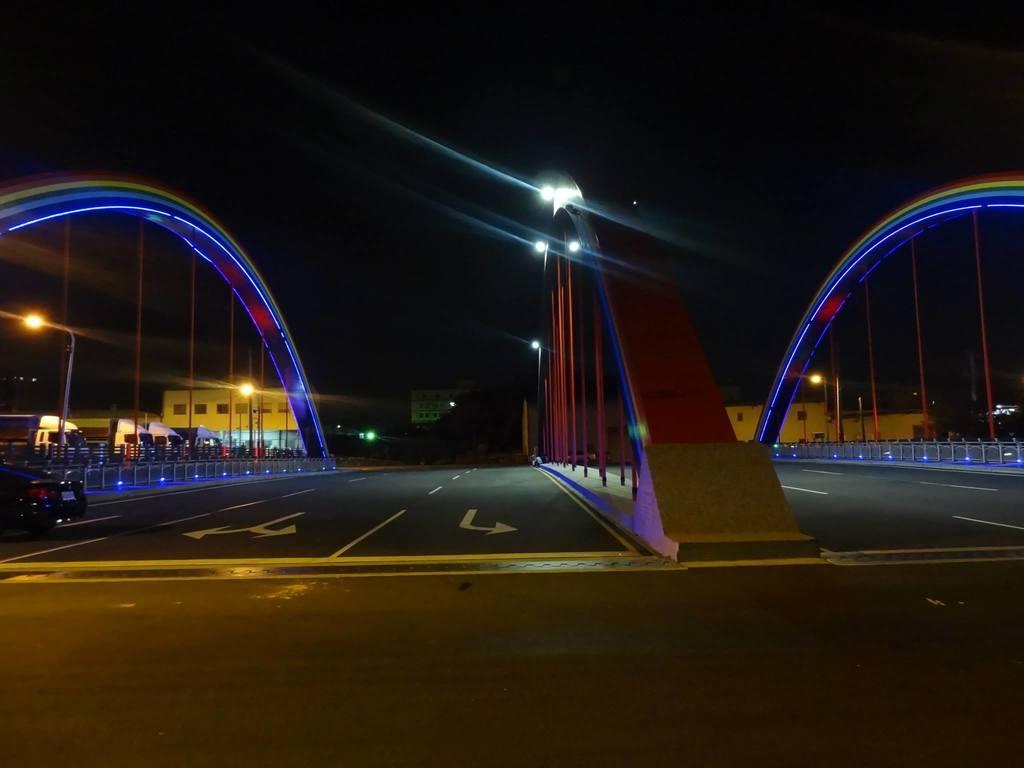How would you summarize this image in a sentence or two? In this image, we can see arches, lights, poles, railings, roads and vehicles. Background we can see buildings, trees, lights and dark view. 